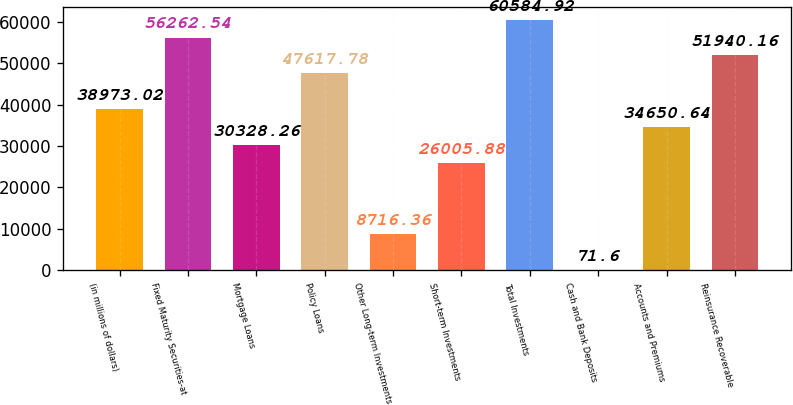<chart> <loc_0><loc_0><loc_500><loc_500><bar_chart><fcel>(in millions of dollars)<fcel>Fixed Maturity Securities-at<fcel>Mortgage Loans<fcel>Policy Loans<fcel>Other Long-term Investments<fcel>Short-term Investments<fcel>Total Investments<fcel>Cash and Bank Deposits<fcel>Accounts and Premiums<fcel>Reinsurance Recoverable<nl><fcel>38973<fcel>56262.5<fcel>30328.3<fcel>47617.8<fcel>8716.36<fcel>26005.9<fcel>60584.9<fcel>71.6<fcel>34650.6<fcel>51940.2<nl></chart> 